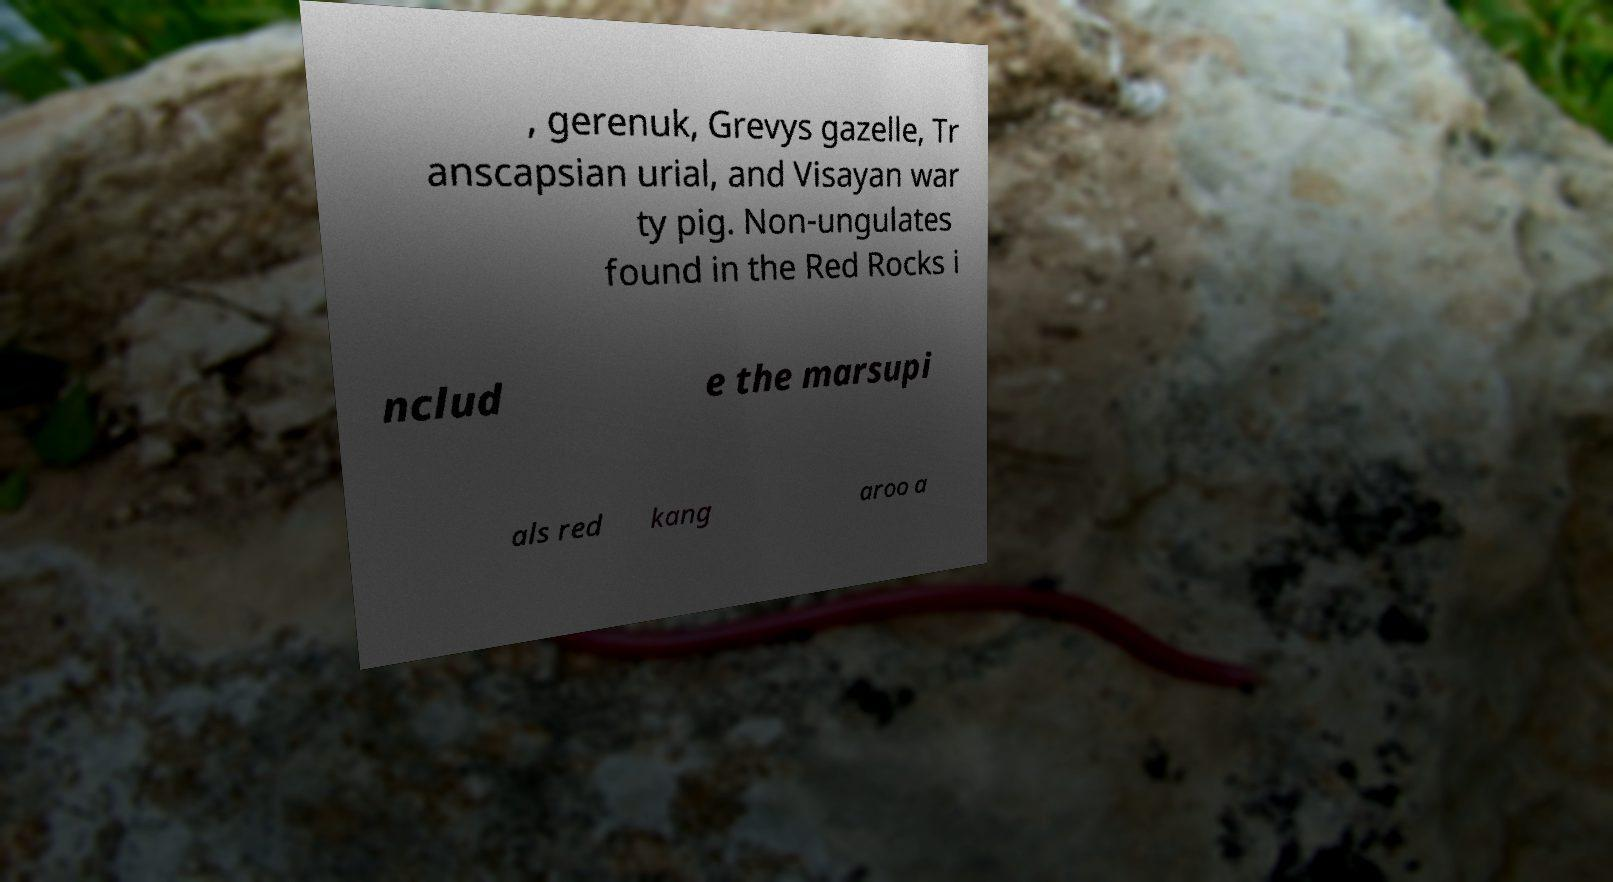There's text embedded in this image that I need extracted. Can you transcribe it verbatim? , gerenuk, Grevys gazelle, Tr anscapsian urial, and Visayan war ty pig. Non-ungulates found in the Red Rocks i nclud e the marsupi als red kang aroo a 